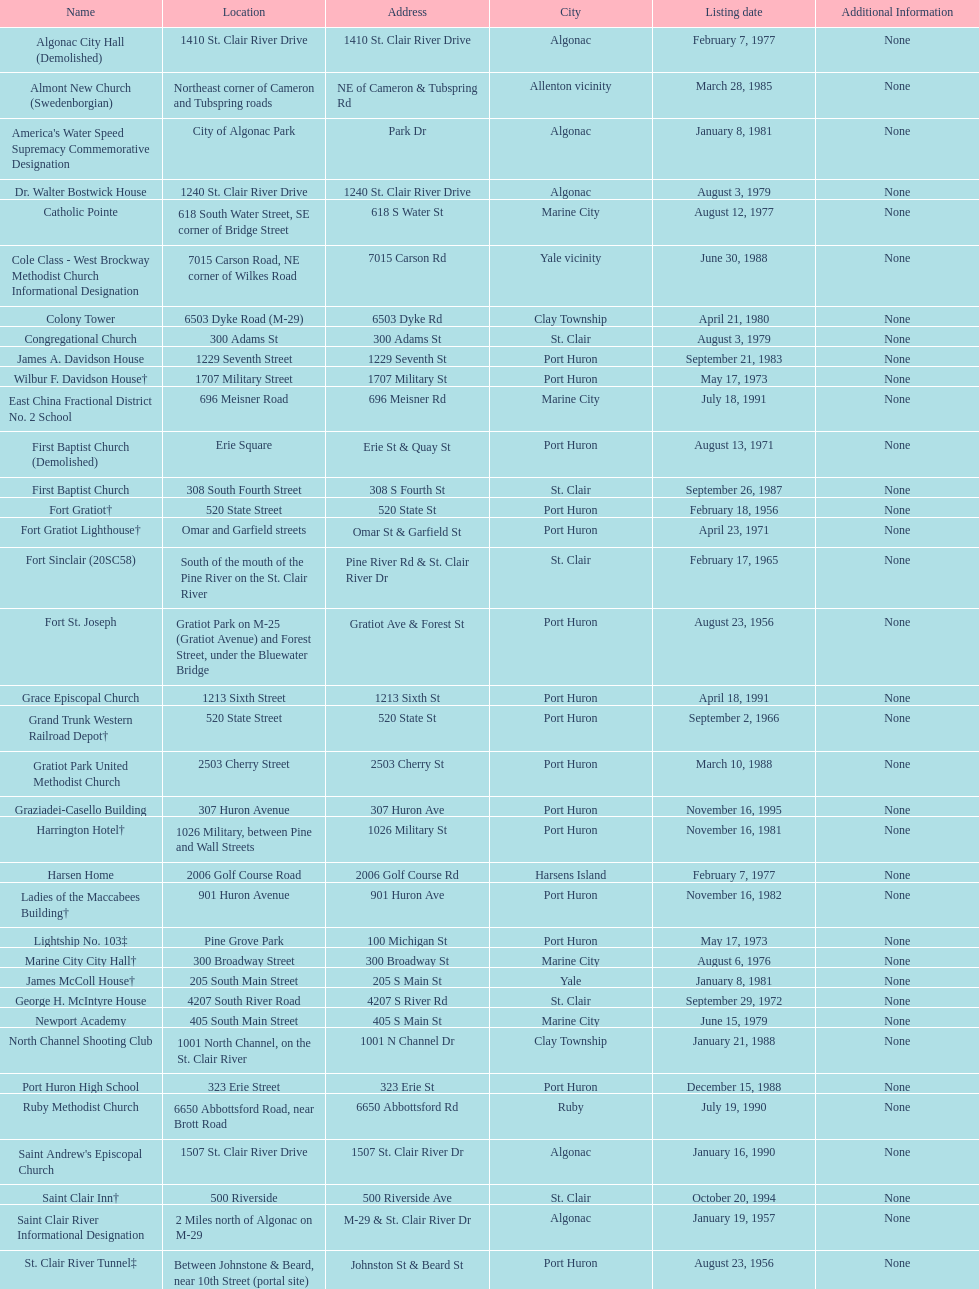Which city is home to the greatest number of historic sites, existing or demolished? Port Huron. 